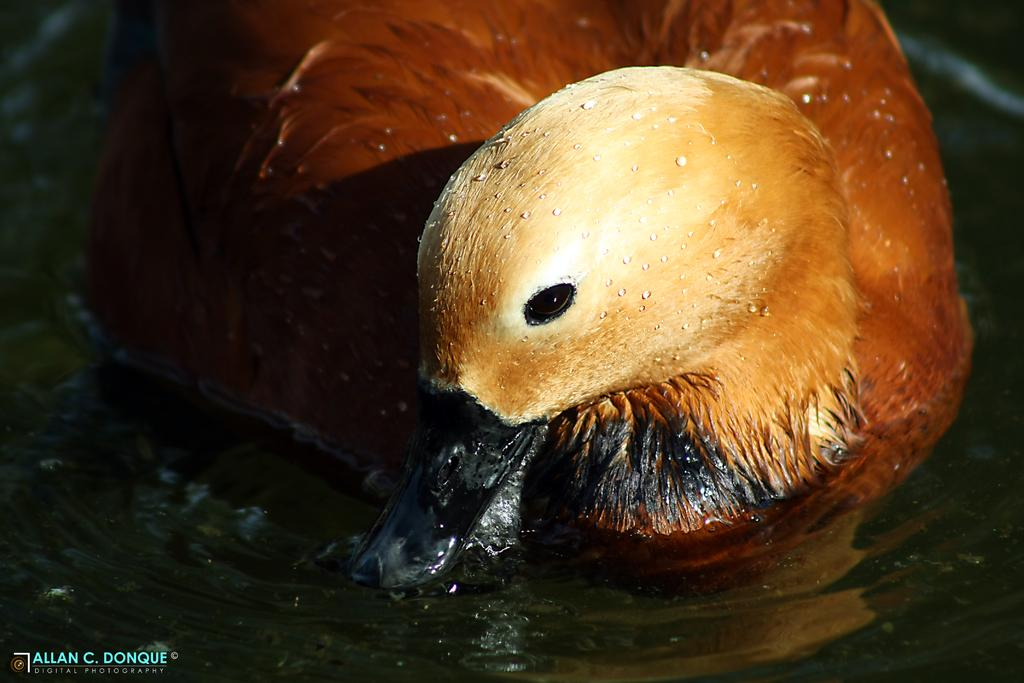What animal is in the foreground of the image? There is a duck in the foreground of the image. Where is the duck located? The duck is on the water. What type of clam can be seen holding an orange while sailing in the image? There is no clam or orange present in the image, and no sailing activity is depicted. 